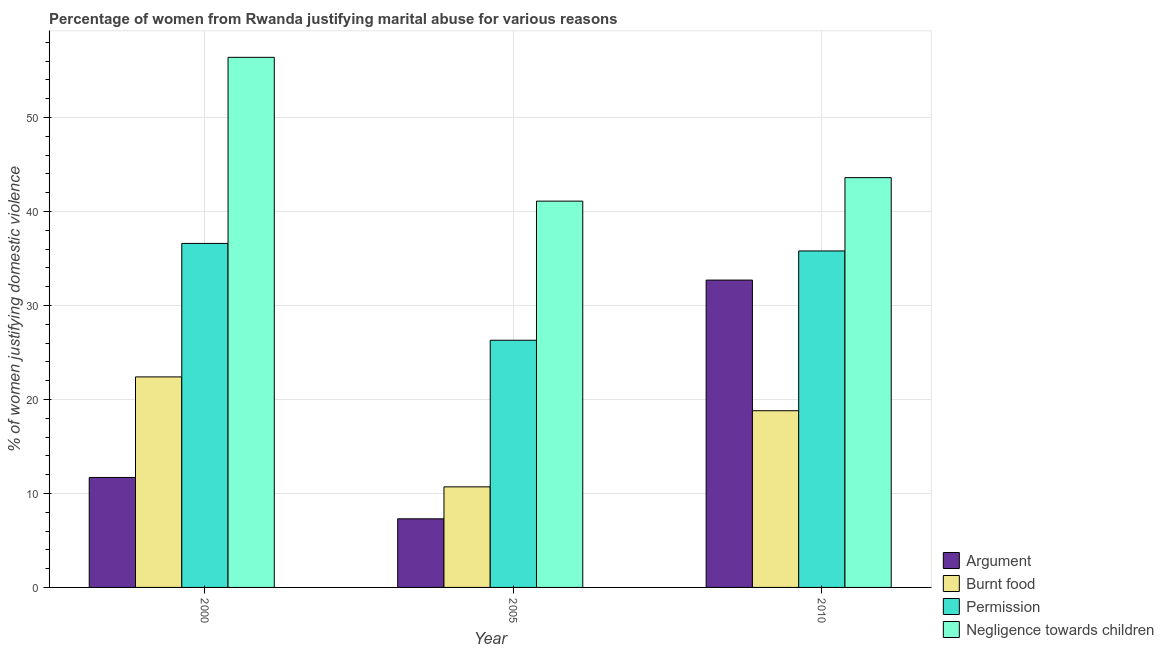How many different coloured bars are there?
Make the answer very short. 4. How many groups of bars are there?
Your answer should be very brief. 3. How many bars are there on the 1st tick from the right?
Give a very brief answer. 4. In how many cases, is the number of bars for a given year not equal to the number of legend labels?
Make the answer very short. 0. What is the percentage of women justifying abuse for showing negligence towards children in 2000?
Keep it short and to the point. 56.4. Across all years, what is the maximum percentage of women justifying abuse for showing negligence towards children?
Keep it short and to the point. 56.4. Across all years, what is the minimum percentage of women justifying abuse for burning food?
Keep it short and to the point. 10.7. What is the total percentage of women justifying abuse for going without permission in the graph?
Give a very brief answer. 98.7. What is the difference between the percentage of women justifying abuse in the case of an argument in 2000 and that in 2010?
Provide a short and direct response. -21. What is the difference between the percentage of women justifying abuse for going without permission in 2005 and the percentage of women justifying abuse for showing negligence towards children in 2010?
Your answer should be very brief. -9.5. What is the average percentage of women justifying abuse for burning food per year?
Provide a short and direct response. 17.3. In the year 2000, what is the difference between the percentage of women justifying abuse for burning food and percentage of women justifying abuse for showing negligence towards children?
Offer a terse response. 0. What is the ratio of the percentage of women justifying abuse for burning food in 2005 to that in 2010?
Your answer should be very brief. 0.57. Is the percentage of women justifying abuse for burning food in 2000 less than that in 2010?
Keep it short and to the point. No. What is the difference between the highest and the second highest percentage of women justifying abuse for burning food?
Give a very brief answer. 3.6. What is the difference between the highest and the lowest percentage of women justifying abuse for showing negligence towards children?
Your answer should be very brief. 15.3. In how many years, is the percentage of women justifying abuse for showing negligence towards children greater than the average percentage of women justifying abuse for showing negligence towards children taken over all years?
Your answer should be very brief. 1. What does the 3rd bar from the left in 2000 represents?
Ensure brevity in your answer.  Permission. What does the 3rd bar from the right in 2010 represents?
Make the answer very short. Burnt food. Are all the bars in the graph horizontal?
Provide a succinct answer. No. How many years are there in the graph?
Offer a very short reply. 3. Does the graph contain grids?
Provide a short and direct response. Yes. Where does the legend appear in the graph?
Your response must be concise. Bottom right. How many legend labels are there?
Your answer should be very brief. 4. How are the legend labels stacked?
Offer a terse response. Vertical. What is the title of the graph?
Your answer should be compact. Percentage of women from Rwanda justifying marital abuse for various reasons. Does "Greece" appear as one of the legend labels in the graph?
Your answer should be compact. No. What is the label or title of the Y-axis?
Make the answer very short. % of women justifying domestic violence. What is the % of women justifying domestic violence in Burnt food in 2000?
Keep it short and to the point. 22.4. What is the % of women justifying domestic violence in Permission in 2000?
Offer a very short reply. 36.6. What is the % of women justifying domestic violence of Negligence towards children in 2000?
Provide a short and direct response. 56.4. What is the % of women justifying domestic violence of Burnt food in 2005?
Ensure brevity in your answer.  10.7. What is the % of women justifying domestic violence in Permission in 2005?
Your response must be concise. 26.3. What is the % of women justifying domestic violence of Negligence towards children in 2005?
Offer a very short reply. 41.1. What is the % of women justifying domestic violence of Argument in 2010?
Offer a terse response. 32.7. What is the % of women justifying domestic violence of Permission in 2010?
Provide a short and direct response. 35.8. What is the % of women justifying domestic violence of Negligence towards children in 2010?
Give a very brief answer. 43.6. Across all years, what is the maximum % of women justifying domestic violence in Argument?
Ensure brevity in your answer.  32.7. Across all years, what is the maximum % of women justifying domestic violence in Burnt food?
Offer a terse response. 22.4. Across all years, what is the maximum % of women justifying domestic violence in Permission?
Provide a short and direct response. 36.6. Across all years, what is the maximum % of women justifying domestic violence in Negligence towards children?
Offer a terse response. 56.4. Across all years, what is the minimum % of women justifying domestic violence of Argument?
Offer a very short reply. 7.3. Across all years, what is the minimum % of women justifying domestic violence in Permission?
Ensure brevity in your answer.  26.3. Across all years, what is the minimum % of women justifying domestic violence in Negligence towards children?
Make the answer very short. 41.1. What is the total % of women justifying domestic violence in Argument in the graph?
Keep it short and to the point. 51.7. What is the total % of women justifying domestic violence in Burnt food in the graph?
Provide a succinct answer. 51.9. What is the total % of women justifying domestic violence of Permission in the graph?
Offer a terse response. 98.7. What is the total % of women justifying domestic violence in Negligence towards children in the graph?
Your response must be concise. 141.1. What is the difference between the % of women justifying domestic violence of Argument in 2000 and that in 2005?
Keep it short and to the point. 4.4. What is the difference between the % of women justifying domestic violence in Permission in 2000 and that in 2005?
Ensure brevity in your answer.  10.3. What is the difference between the % of women justifying domestic violence in Negligence towards children in 2000 and that in 2005?
Offer a terse response. 15.3. What is the difference between the % of women justifying domestic violence in Argument in 2000 and that in 2010?
Offer a very short reply. -21. What is the difference between the % of women justifying domestic violence in Argument in 2005 and that in 2010?
Your answer should be compact. -25.4. What is the difference between the % of women justifying domestic violence of Negligence towards children in 2005 and that in 2010?
Keep it short and to the point. -2.5. What is the difference between the % of women justifying domestic violence of Argument in 2000 and the % of women justifying domestic violence of Permission in 2005?
Your answer should be compact. -14.6. What is the difference between the % of women justifying domestic violence of Argument in 2000 and the % of women justifying domestic violence of Negligence towards children in 2005?
Give a very brief answer. -29.4. What is the difference between the % of women justifying domestic violence of Burnt food in 2000 and the % of women justifying domestic violence of Negligence towards children in 2005?
Your answer should be very brief. -18.7. What is the difference between the % of women justifying domestic violence of Argument in 2000 and the % of women justifying domestic violence of Burnt food in 2010?
Give a very brief answer. -7.1. What is the difference between the % of women justifying domestic violence of Argument in 2000 and the % of women justifying domestic violence of Permission in 2010?
Ensure brevity in your answer.  -24.1. What is the difference between the % of women justifying domestic violence in Argument in 2000 and the % of women justifying domestic violence in Negligence towards children in 2010?
Ensure brevity in your answer.  -31.9. What is the difference between the % of women justifying domestic violence in Burnt food in 2000 and the % of women justifying domestic violence in Permission in 2010?
Offer a terse response. -13.4. What is the difference between the % of women justifying domestic violence of Burnt food in 2000 and the % of women justifying domestic violence of Negligence towards children in 2010?
Provide a succinct answer. -21.2. What is the difference between the % of women justifying domestic violence in Permission in 2000 and the % of women justifying domestic violence in Negligence towards children in 2010?
Your answer should be compact. -7. What is the difference between the % of women justifying domestic violence of Argument in 2005 and the % of women justifying domestic violence of Burnt food in 2010?
Offer a terse response. -11.5. What is the difference between the % of women justifying domestic violence in Argument in 2005 and the % of women justifying domestic violence in Permission in 2010?
Offer a very short reply. -28.5. What is the difference between the % of women justifying domestic violence of Argument in 2005 and the % of women justifying domestic violence of Negligence towards children in 2010?
Your answer should be very brief. -36.3. What is the difference between the % of women justifying domestic violence in Burnt food in 2005 and the % of women justifying domestic violence in Permission in 2010?
Give a very brief answer. -25.1. What is the difference between the % of women justifying domestic violence of Burnt food in 2005 and the % of women justifying domestic violence of Negligence towards children in 2010?
Offer a terse response. -32.9. What is the difference between the % of women justifying domestic violence of Permission in 2005 and the % of women justifying domestic violence of Negligence towards children in 2010?
Your answer should be compact. -17.3. What is the average % of women justifying domestic violence of Argument per year?
Give a very brief answer. 17.23. What is the average % of women justifying domestic violence of Permission per year?
Ensure brevity in your answer.  32.9. What is the average % of women justifying domestic violence in Negligence towards children per year?
Ensure brevity in your answer.  47.03. In the year 2000, what is the difference between the % of women justifying domestic violence of Argument and % of women justifying domestic violence of Permission?
Make the answer very short. -24.9. In the year 2000, what is the difference between the % of women justifying domestic violence of Argument and % of women justifying domestic violence of Negligence towards children?
Provide a short and direct response. -44.7. In the year 2000, what is the difference between the % of women justifying domestic violence in Burnt food and % of women justifying domestic violence in Permission?
Your response must be concise. -14.2. In the year 2000, what is the difference between the % of women justifying domestic violence of Burnt food and % of women justifying domestic violence of Negligence towards children?
Keep it short and to the point. -34. In the year 2000, what is the difference between the % of women justifying domestic violence in Permission and % of women justifying domestic violence in Negligence towards children?
Provide a succinct answer. -19.8. In the year 2005, what is the difference between the % of women justifying domestic violence of Argument and % of women justifying domestic violence of Negligence towards children?
Your answer should be very brief. -33.8. In the year 2005, what is the difference between the % of women justifying domestic violence in Burnt food and % of women justifying domestic violence in Permission?
Your answer should be very brief. -15.6. In the year 2005, what is the difference between the % of women justifying domestic violence in Burnt food and % of women justifying domestic violence in Negligence towards children?
Provide a succinct answer. -30.4. In the year 2005, what is the difference between the % of women justifying domestic violence of Permission and % of women justifying domestic violence of Negligence towards children?
Make the answer very short. -14.8. In the year 2010, what is the difference between the % of women justifying domestic violence in Argument and % of women justifying domestic violence in Permission?
Your answer should be compact. -3.1. In the year 2010, what is the difference between the % of women justifying domestic violence of Burnt food and % of women justifying domestic violence of Permission?
Give a very brief answer. -17. In the year 2010, what is the difference between the % of women justifying domestic violence in Burnt food and % of women justifying domestic violence in Negligence towards children?
Provide a succinct answer. -24.8. In the year 2010, what is the difference between the % of women justifying domestic violence of Permission and % of women justifying domestic violence of Negligence towards children?
Keep it short and to the point. -7.8. What is the ratio of the % of women justifying domestic violence in Argument in 2000 to that in 2005?
Your answer should be very brief. 1.6. What is the ratio of the % of women justifying domestic violence in Burnt food in 2000 to that in 2005?
Offer a very short reply. 2.09. What is the ratio of the % of women justifying domestic violence of Permission in 2000 to that in 2005?
Your response must be concise. 1.39. What is the ratio of the % of women justifying domestic violence of Negligence towards children in 2000 to that in 2005?
Provide a succinct answer. 1.37. What is the ratio of the % of women justifying domestic violence in Argument in 2000 to that in 2010?
Give a very brief answer. 0.36. What is the ratio of the % of women justifying domestic violence of Burnt food in 2000 to that in 2010?
Provide a short and direct response. 1.19. What is the ratio of the % of women justifying domestic violence in Permission in 2000 to that in 2010?
Your answer should be very brief. 1.02. What is the ratio of the % of women justifying domestic violence of Negligence towards children in 2000 to that in 2010?
Keep it short and to the point. 1.29. What is the ratio of the % of women justifying domestic violence in Argument in 2005 to that in 2010?
Give a very brief answer. 0.22. What is the ratio of the % of women justifying domestic violence in Burnt food in 2005 to that in 2010?
Your response must be concise. 0.57. What is the ratio of the % of women justifying domestic violence of Permission in 2005 to that in 2010?
Provide a short and direct response. 0.73. What is the ratio of the % of women justifying domestic violence in Negligence towards children in 2005 to that in 2010?
Offer a very short reply. 0.94. What is the difference between the highest and the second highest % of women justifying domestic violence of Burnt food?
Offer a terse response. 3.6. What is the difference between the highest and the second highest % of women justifying domestic violence of Negligence towards children?
Offer a terse response. 12.8. What is the difference between the highest and the lowest % of women justifying domestic violence in Argument?
Offer a very short reply. 25.4. What is the difference between the highest and the lowest % of women justifying domestic violence of Burnt food?
Your answer should be compact. 11.7. What is the difference between the highest and the lowest % of women justifying domestic violence of Negligence towards children?
Offer a very short reply. 15.3. 